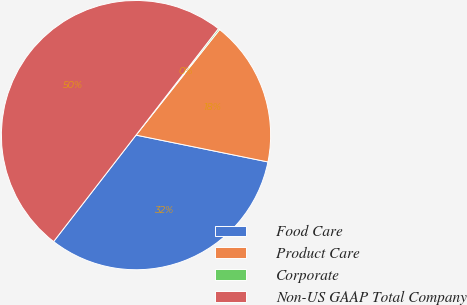<chart> <loc_0><loc_0><loc_500><loc_500><pie_chart><fcel>Food Care<fcel>Product Care<fcel>Corporate<fcel>Non-US GAAP Total Company<nl><fcel>32.29%<fcel>17.53%<fcel>0.18%<fcel>50.0%<nl></chart> 